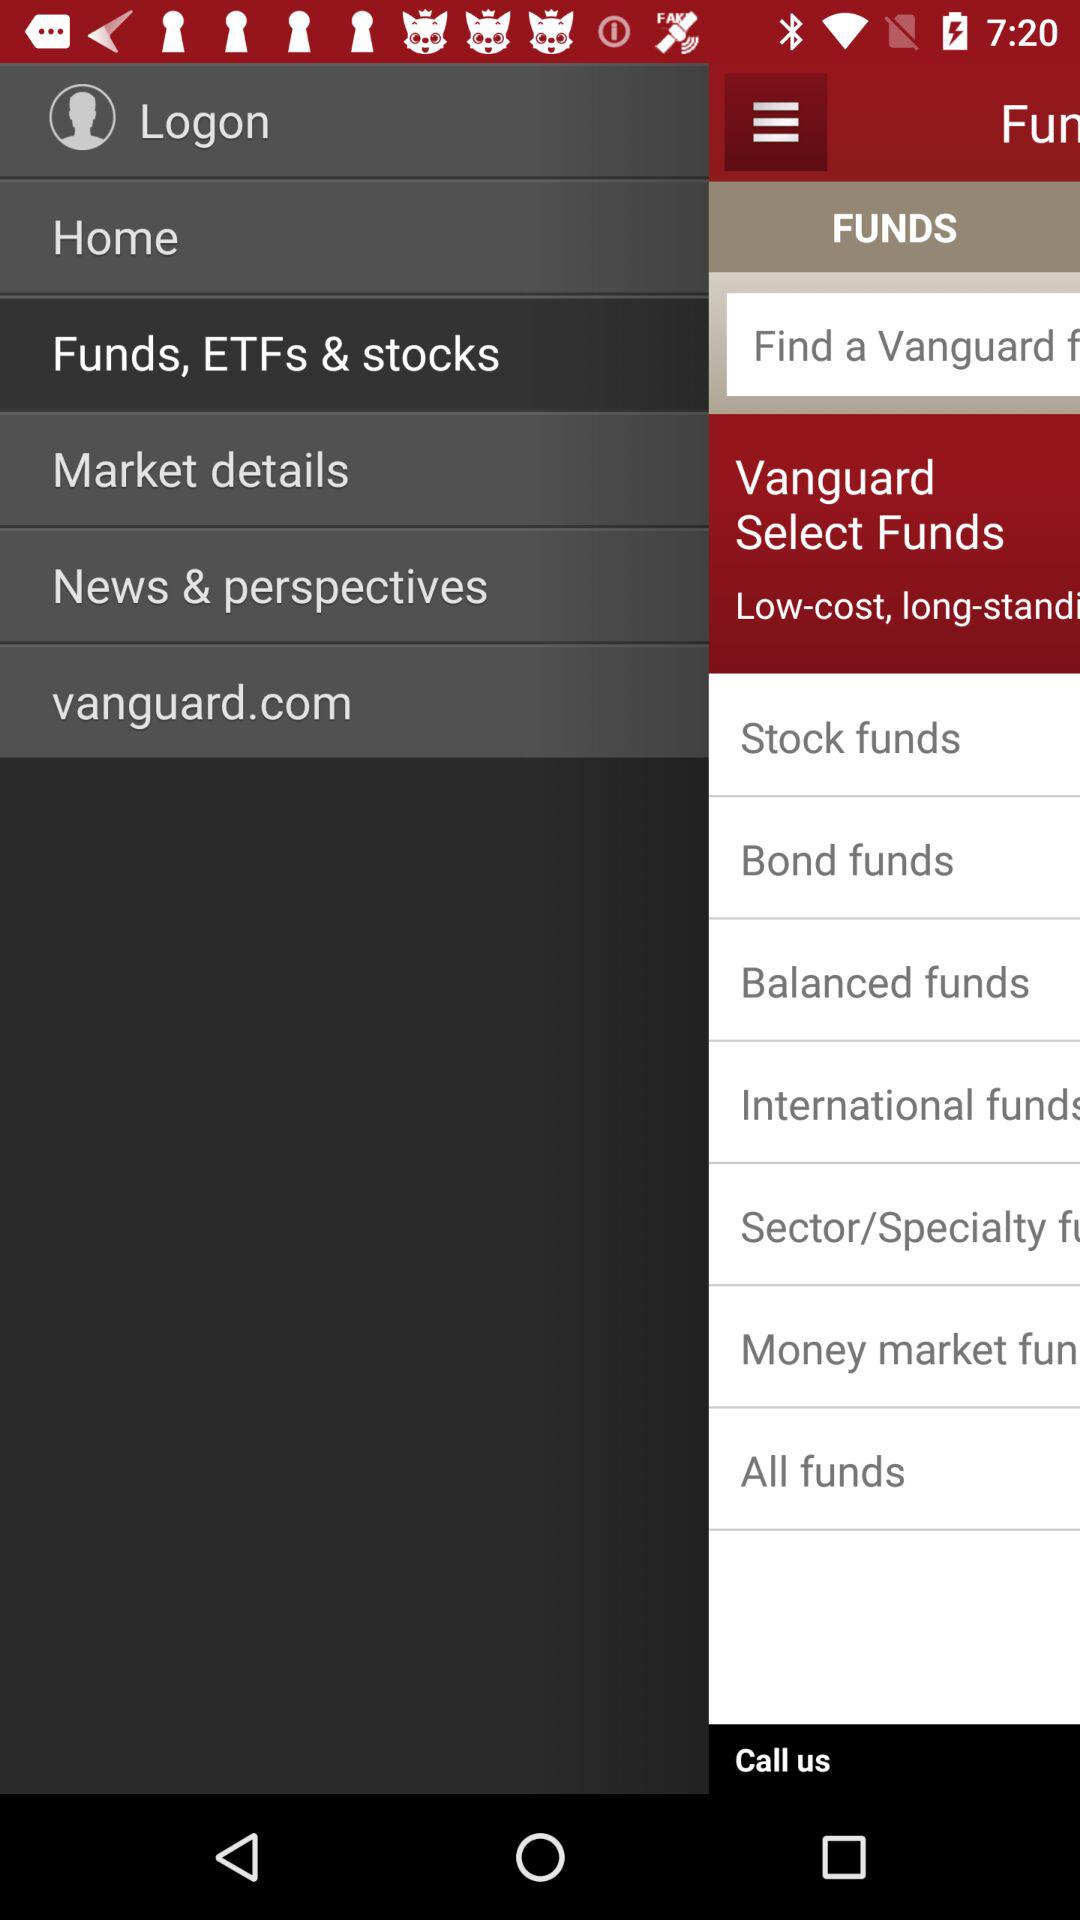What's the selected item in the menu? The selected item is "Funds, ETFs & stocks". 